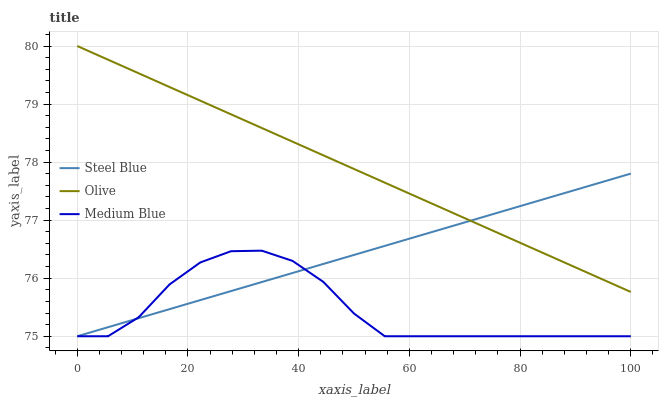Does Medium Blue have the minimum area under the curve?
Answer yes or no. Yes. Does Olive have the maximum area under the curve?
Answer yes or no. Yes. Does Steel Blue have the minimum area under the curve?
Answer yes or no. No. Does Steel Blue have the maximum area under the curve?
Answer yes or no. No. Is Steel Blue the smoothest?
Answer yes or no. Yes. Is Medium Blue the roughest?
Answer yes or no. Yes. Is Medium Blue the smoothest?
Answer yes or no. No. Is Steel Blue the roughest?
Answer yes or no. No. Does Medium Blue have the lowest value?
Answer yes or no. Yes. Does Olive have the highest value?
Answer yes or no. Yes. Does Steel Blue have the highest value?
Answer yes or no. No. Is Medium Blue less than Olive?
Answer yes or no. Yes. Is Olive greater than Medium Blue?
Answer yes or no. Yes. Does Medium Blue intersect Steel Blue?
Answer yes or no. Yes. Is Medium Blue less than Steel Blue?
Answer yes or no. No. Is Medium Blue greater than Steel Blue?
Answer yes or no. No. Does Medium Blue intersect Olive?
Answer yes or no. No. 